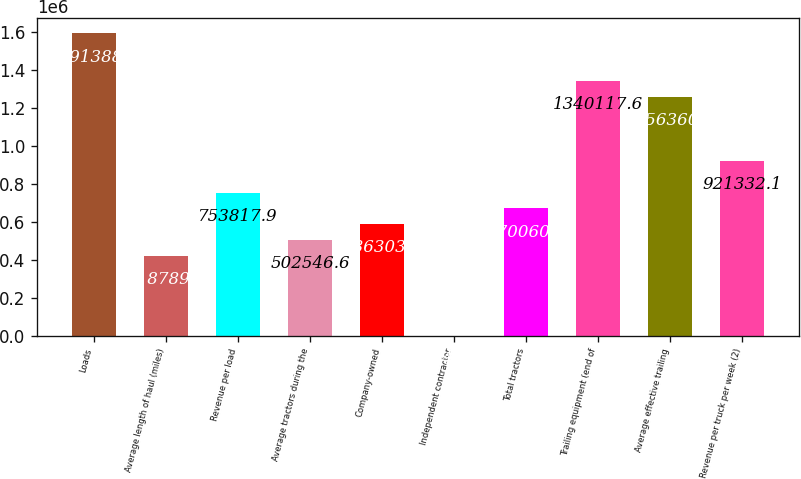<chart> <loc_0><loc_0><loc_500><loc_500><bar_chart><fcel>Loads<fcel>Average length of haul (miles)<fcel>Revenue per load<fcel>Average tractors during the<fcel>Company-owned<fcel>Independent contractor<fcel>Total tractors<fcel>Trailing equipment (end of<fcel>Average effective trailing<fcel>Revenue per truck per week (2)<nl><fcel>1.59139e+06<fcel>418790<fcel>753818<fcel>502547<fcel>586304<fcel>4<fcel>670061<fcel>1.34012e+06<fcel>1.25636e+06<fcel>921332<nl></chart> 